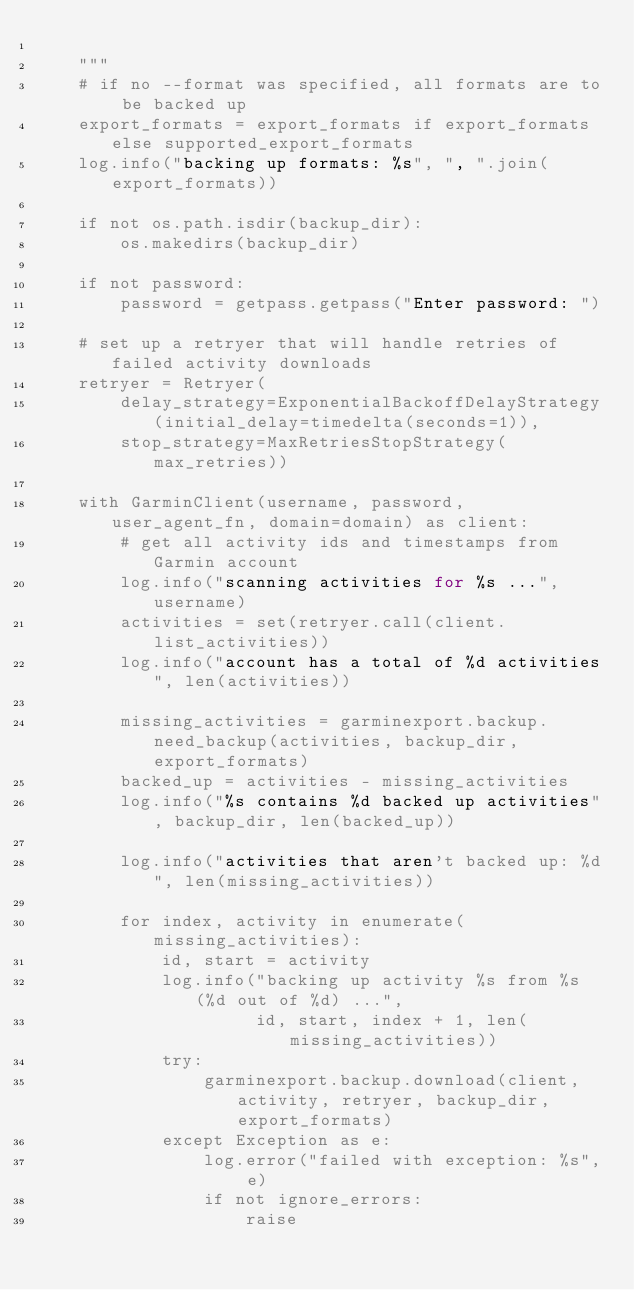<code> <loc_0><loc_0><loc_500><loc_500><_Python_>
    """
    # if no --format was specified, all formats are to be backed up
    export_formats = export_formats if export_formats else supported_export_formats
    log.info("backing up formats: %s", ", ".join(export_formats))

    if not os.path.isdir(backup_dir):
        os.makedirs(backup_dir)

    if not password:
        password = getpass.getpass("Enter password: ")

    # set up a retryer that will handle retries of failed activity downloads
    retryer = Retryer(
        delay_strategy=ExponentialBackoffDelayStrategy(initial_delay=timedelta(seconds=1)),
        stop_strategy=MaxRetriesStopStrategy(max_retries))

    with GarminClient(username, password, user_agent_fn, domain=domain) as client:
        # get all activity ids and timestamps from Garmin account
        log.info("scanning activities for %s ...", username)
        activities = set(retryer.call(client.list_activities))
        log.info("account has a total of %d activities", len(activities))

        missing_activities = garminexport.backup.need_backup(activities, backup_dir, export_formats)
        backed_up = activities - missing_activities
        log.info("%s contains %d backed up activities", backup_dir, len(backed_up))

        log.info("activities that aren't backed up: %d", len(missing_activities))

        for index, activity in enumerate(missing_activities):
            id, start = activity
            log.info("backing up activity %s from %s (%d out of %d) ...",
                     id, start, index + 1, len(missing_activities))
            try:
                garminexport.backup.download(client, activity, retryer, backup_dir, export_formats)
            except Exception as e:
                log.error("failed with exception: %s", e)
                if not ignore_errors:
                    raise
</code> 